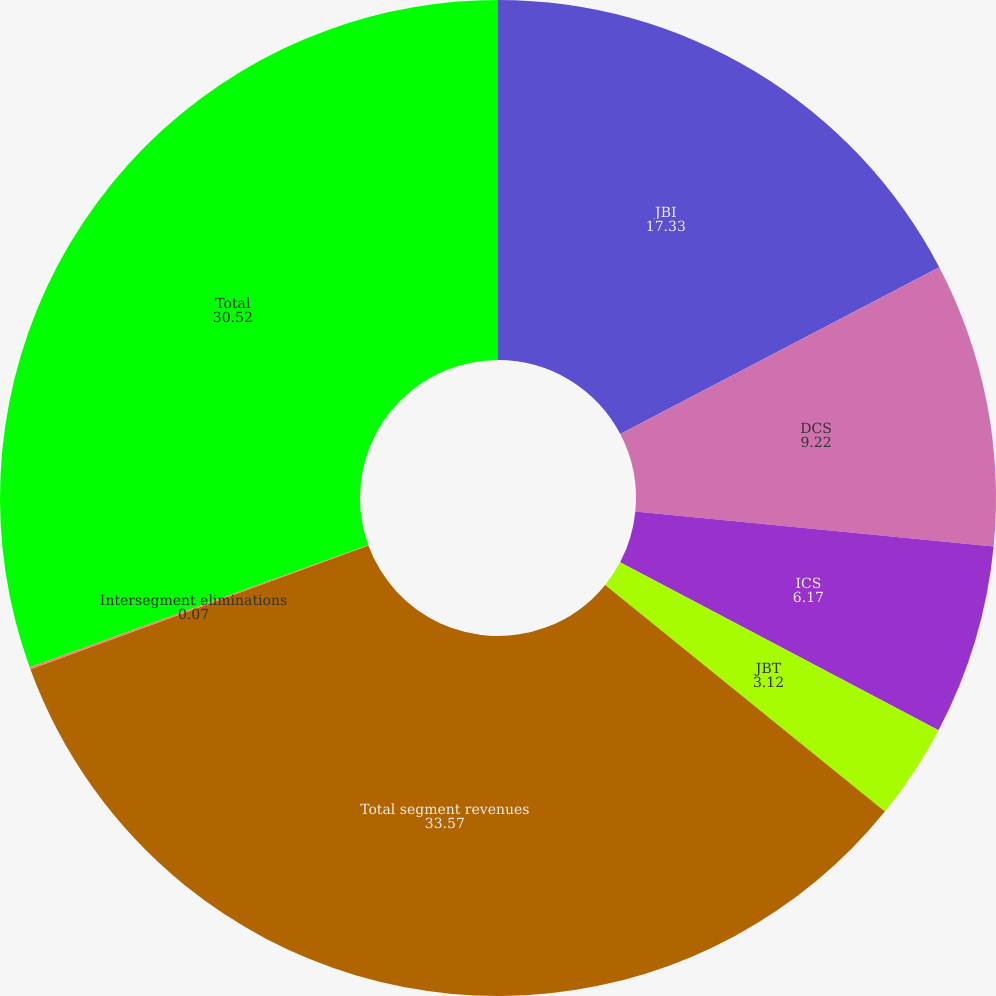<chart> <loc_0><loc_0><loc_500><loc_500><pie_chart><fcel>JBI<fcel>DCS<fcel>ICS<fcel>JBT<fcel>Total segment revenues<fcel>Intersegment eliminations<fcel>Total<nl><fcel>17.33%<fcel>9.22%<fcel>6.17%<fcel>3.12%<fcel>33.57%<fcel>0.07%<fcel>30.52%<nl></chart> 